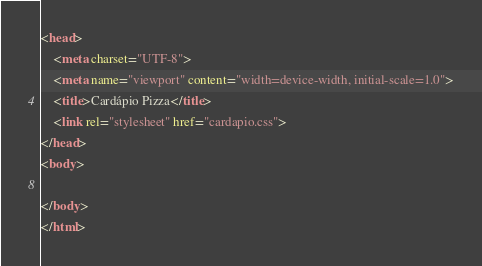Convert code to text. <code><loc_0><loc_0><loc_500><loc_500><_HTML_><head>
    <meta charset="UTF-8">
    <meta name="viewport" content="width=device-width, initial-scale=1.0">
    <title>Cardápio Pizza</title>
    <link rel="stylesheet" href="cardapio.css">
</head>
<body>
    
</body>
</html></code> 